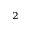Convert formula to latex. <formula><loc_0><loc_0><loc_500><loc_500>_ { 2 }</formula> 